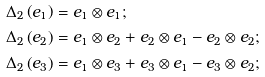<formula> <loc_0><loc_0><loc_500><loc_500>\Delta _ { 2 } \left ( e _ { 1 } \right ) & = e _ { 1 } \otimes e _ { 1 } ; \\ \Delta _ { 2 } \left ( e _ { 2 } \right ) & = e _ { 1 } \otimes e _ { 2 } + e _ { 2 } \otimes e _ { 1 } - e _ { 2 } \otimes e _ { 2 } ; \\ \Delta _ { 2 } \left ( e _ { 3 } \right ) & = e _ { 1 } \otimes e _ { 3 } + e _ { 3 } \otimes e _ { 1 } - e _ { 3 } \otimes e _ { 2 } ; \</formula> 